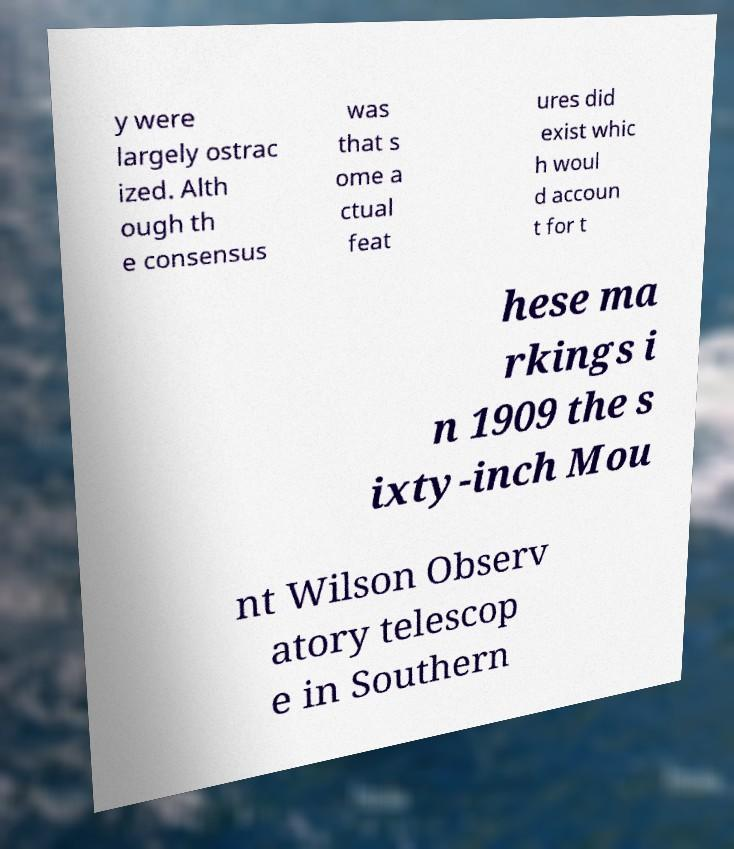Can you read and provide the text displayed in the image?This photo seems to have some interesting text. Can you extract and type it out for me? y were largely ostrac ized. Alth ough th e consensus was that s ome a ctual feat ures did exist whic h woul d accoun t for t hese ma rkings i n 1909 the s ixty-inch Mou nt Wilson Observ atory telescop e in Southern 